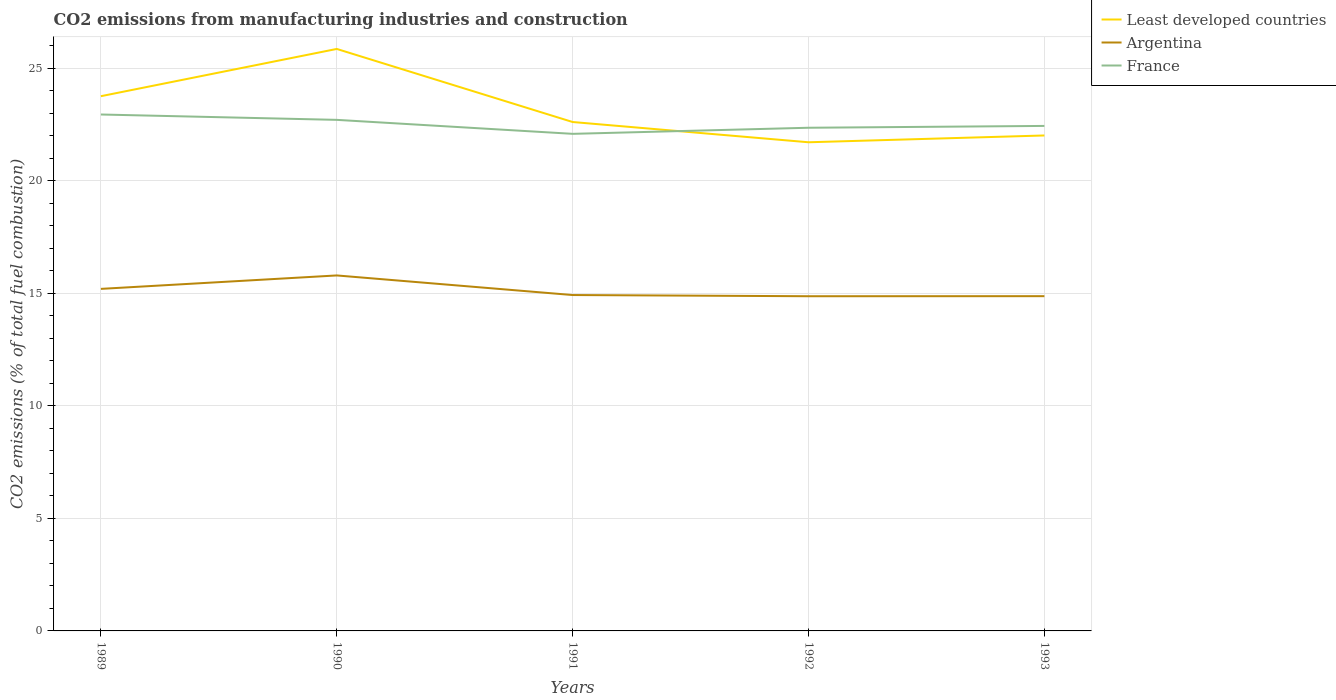How many different coloured lines are there?
Your answer should be very brief. 3. Does the line corresponding to Argentina intersect with the line corresponding to France?
Make the answer very short. No. Across all years, what is the maximum amount of CO2 emitted in Least developed countries?
Provide a short and direct response. 21.71. In which year was the amount of CO2 emitted in Least developed countries maximum?
Make the answer very short. 1992. What is the total amount of CO2 emitted in Argentina in the graph?
Your answer should be compact. -0.6. What is the difference between the highest and the second highest amount of CO2 emitted in France?
Ensure brevity in your answer.  0.86. What is the difference between the highest and the lowest amount of CO2 emitted in Argentina?
Keep it short and to the point. 2. Is the amount of CO2 emitted in Least developed countries strictly greater than the amount of CO2 emitted in Argentina over the years?
Provide a short and direct response. No. How many lines are there?
Ensure brevity in your answer.  3. How many years are there in the graph?
Provide a succinct answer. 5. Are the values on the major ticks of Y-axis written in scientific E-notation?
Provide a succinct answer. No. Where does the legend appear in the graph?
Offer a terse response. Top right. How many legend labels are there?
Give a very brief answer. 3. What is the title of the graph?
Provide a succinct answer. CO2 emissions from manufacturing industries and construction. What is the label or title of the Y-axis?
Provide a short and direct response. CO2 emissions (% of total fuel combustion). What is the CO2 emissions (% of total fuel combustion) of Least developed countries in 1989?
Provide a succinct answer. 23.75. What is the CO2 emissions (% of total fuel combustion) of Argentina in 1989?
Provide a succinct answer. 15.2. What is the CO2 emissions (% of total fuel combustion) in France in 1989?
Keep it short and to the point. 22.94. What is the CO2 emissions (% of total fuel combustion) of Least developed countries in 1990?
Your answer should be very brief. 25.85. What is the CO2 emissions (% of total fuel combustion) in Argentina in 1990?
Give a very brief answer. 15.79. What is the CO2 emissions (% of total fuel combustion) of France in 1990?
Your answer should be compact. 22.7. What is the CO2 emissions (% of total fuel combustion) of Least developed countries in 1991?
Offer a terse response. 22.61. What is the CO2 emissions (% of total fuel combustion) in Argentina in 1991?
Keep it short and to the point. 14.92. What is the CO2 emissions (% of total fuel combustion) of France in 1991?
Provide a short and direct response. 22.08. What is the CO2 emissions (% of total fuel combustion) of Least developed countries in 1992?
Make the answer very short. 21.71. What is the CO2 emissions (% of total fuel combustion) of Argentina in 1992?
Make the answer very short. 14.87. What is the CO2 emissions (% of total fuel combustion) of France in 1992?
Provide a succinct answer. 22.35. What is the CO2 emissions (% of total fuel combustion) in Least developed countries in 1993?
Offer a very short reply. 22.01. What is the CO2 emissions (% of total fuel combustion) of Argentina in 1993?
Offer a very short reply. 14.87. What is the CO2 emissions (% of total fuel combustion) of France in 1993?
Offer a terse response. 22.43. Across all years, what is the maximum CO2 emissions (% of total fuel combustion) in Least developed countries?
Your answer should be very brief. 25.85. Across all years, what is the maximum CO2 emissions (% of total fuel combustion) of Argentina?
Your response must be concise. 15.79. Across all years, what is the maximum CO2 emissions (% of total fuel combustion) in France?
Provide a short and direct response. 22.94. Across all years, what is the minimum CO2 emissions (% of total fuel combustion) of Least developed countries?
Offer a terse response. 21.71. Across all years, what is the minimum CO2 emissions (% of total fuel combustion) of Argentina?
Make the answer very short. 14.87. Across all years, what is the minimum CO2 emissions (% of total fuel combustion) of France?
Your response must be concise. 22.08. What is the total CO2 emissions (% of total fuel combustion) in Least developed countries in the graph?
Your answer should be very brief. 115.93. What is the total CO2 emissions (% of total fuel combustion) in Argentina in the graph?
Your answer should be compact. 75.65. What is the total CO2 emissions (% of total fuel combustion) in France in the graph?
Your answer should be compact. 112.51. What is the difference between the CO2 emissions (% of total fuel combustion) of Least developed countries in 1989 and that in 1990?
Your answer should be very brief. -2.1. What is the difference between the CO2 emissions (% of total fuel combustion) of Argentina in 1989 and that in 1990?
Your response must be concise. -0.6. What is the difference between the CO2 emissions (% of total fuel combustion) of France in 1989 and that in 1990?
Make the answer very short. 0.24. What is the difference between the CO2 emissions (% of total fuel combustion) in Least developed countries in 1989 and that in 1991?
Provide a succinct answer. 1.15. What is the difference between the CO2 emissions (% of total fuel combustion) in Argentina in 1989 and that in 1991?
Your response must be concise. 0.27. What is the difference between the CO2 emissions (% of total fuel combustion) of France in 1989 and that in 1991?
Your answer should be very brief. 0.86. What is the difference between the CO2 emissions (% of total fuel combustion) in Least developed countries in 1989 and that in 1992?
Offer a terse response. 2.05. What is the difference between the CO2 emissions (% of total fuel combustion) of Argentina in 1989 and that in 1992?
Your answer should be compact. 0.33. What is the difference between the CO2 emissions (% of total fuel combustion) in France in 1989 and that in 1992?
Give a very brief answer. 0.59. What is the difference between the CO2 emissions (% of total fuel combustion) of Least developed countries in 1989 and that in 1993?
Offer a very short reply. 1.74. What is the difference between the CO2 emissions (% of total fuel combustion) in Argentina in 1989 and that in 1993?
Provide a short and direct response. 0.32. What is the difference between the CO2 emissions (% of total fuel combustion) in France in 1989 and that in 1993?
Ensure brevity in your answer.  0.51. What is the difference between the CO2 emissions (% of total fuel combustion) of Least developed countries in 1990 and that in 1991?
Your answer should be compact. 3.25. What is the difference between the CO2 emissions (% of total fuel combustion) in Argentina in 1990 and that in 1991?
Your answer should be very brief. 0.87. What is the difference between the CO2 emissions (% of total fuel combustion) in France in 1990 and that in 1991?
Keep it short and to the point. 0.62. What is the difference between the CO2 emissions (% of total fuel combustion) of Least developed countries in 1990 and that in 1992?
Offer a terse response. 4.15. What is the difference between the CO2 emissions (% of total fuel combustion) in Argentina in 1990 and that in 1992?
Offer a very short reply. 0.92. What is the difference between the CO2 emissions (% of total fuel combustion) in France in 1990 and that in 1992?
Give a very brief answer. 0.35. What is the difference between the CO2 emissions (% of total fuel combustion) of Least developed countries in 1990 and that in 1993?
Your answer should be compact. 3.84. What is the difference between the CO2 emissions (% of total fuel combustion) in Argentina in 1990 and that in 1993?
Offer a very short reply. 0.92. What is the difference between the CO2 emissions (% of total fuel combustion) in France in 1990 and that in 1993?
Your response must be concise. 0.27. What is the difference between the CO2 emissions (% of total fuel combustion) of Least developed countries in 1991 and that in 1992?
Your response must be concise. 0.9. What is the difference between the CO2 emissions (% of total fuel combustion) of Argentina in 1991 and that in 1992?
Provide a short and direct response. 0.05. What is the difference between the CO2 emissions (% of total fuel combustion) in France in 1991 and that in 1992?
Offer a terse response. -0.27. What is the difference between the CO2 emissions (% of total fuel combustion) in Least developed countries in 1991 and that in 1993?
Your response must be concise. 0.6. What is the difference between the CO2 emissions (% of total fuel combustion) of France in 1991 and that in 1993?
Provide a succinct answer. -0.35. What is the difference between the CO2 emissions (% of total fuel combustion) in Least developed countries in 1992 and that in 1993?
Provide a short and direct response. -0.3. What is the difference between the CO2 emissions (% of total fuel combustion) of Argentina in 1992 and that in 1993?
Ensure brevity in your answer.  -0. What is the difference between the CO2 emissions (% of total fuel combustion) of France in 1992 and that in 1993?
Provide a short and direct response. -0.08. What is the difference between the CO2 emissions (% of total fuel combustion) of Least developed countries in 1989 and the CO2 emissions (% of total fuel combustion) of Argentina in 1990?
Provide a short and direct response. 7.96. What is the difference between the CO2 emissions (% of total fuel combustion) of Least developed countries in 1989 and the CO2 emissions (% of total fuel combustion) of France in 1990?
Your answer should be compact. 1.05. What is the difference between the CO2 emissions (% of total fuel combustion) in Argentina in 1989 and the CO2 emissions (% of total fuel combustion) in France in 1990?
Offer a very short reply. -7.51. What is the difference between the CO2 emissions (% of total fuel combustion) of Least developed countries in 1989 and the CO2 emissions (% of total fuel combustion) of Argentina in 1991?
Make the answer very short. 8.83. What is the difference between the CO2 emissions (% of total fuel combustion) in Least developed countries in 1989 and the CO2 emissions (% of total fuel combustion) in France in 1991?
Offer a terse response. 1.67. What is the difference between the CO2 emissions (% of total fuel combustion) in Argentina in 1989 and the CO2 emissions (% of total fuel combustion) in France in 1991?
Your answer should be very brief. -6.89. What is the difference between the CO2 emissions (% of total fuel combustion) in Least developed countries in 1989 and the CO2 emissions (% of total fuel combustion) in Argentina in 1992?
Ensure brevity in your answer.  8.89. What is the difference between the CO2 emissions (% of total fuel combustion) in Least developed countries in 1989 and the CO2 emissions (% of total fuel combustion) in France in 1992?
Your answer should be compact. 1.4. What is the difference between the CO2 emissions (% of total fuel combustion) of Argentina in 1989 and the CO2 emissions (% of total fuel combustion) of France in 1992?
Your response must be concise. -7.16. What is the difference between the CO2 emissions (% of total fuel combustion) in Least developed countries in 1989 and the CO2 emissions (% of total fuel combustion) in Argentina in 1993?
Your response must be concise. 8.88. What is the difference between the CO2 emissions (% of total fuel combustion) of Least developed countries in 1989 and the CO2 emissions (% of total fuel combustion) of France in 1993?
Your response must be concise. 1.32. What is the difference between the CO2 emissions (% of total fuel combustion) of Argentina in 1989 and the CO2 emissions (% of total fuel combustion) of France in 1993?
Offer a terse response. -7.24. What is the difference between the CO2 emissions (% of total fuel combustion) in Least developed countries in 1990 and the CO2 emissions (% of total fuel combustion) in Argentina in 1991?
Give a very brief answer. 10.93. What is the difference between the CO2 emissions (% of total fuel combustion) of Least developed countries in 1990 and the CO2 emissions (% of total fuel combustion) of France in 1991?
Your response must be concise. 3.77. What is the difference between the CO2 emissions (% of total fuel combustion) of Argentina in 1990 and the CO2 emissions (% of total fuel combustion) of France in 1991?
Provide a succinct answer. -6.29. What is the difference between the CO2 emissions (% of total fuel combustion) in Least developed countries in 1990 and the CO2 emissions (% of total fuel combustion) in Argentina in 1992?
Your answer should be compact. 10.99. What is the difference between the CO2 emissions (% of total fuel combustion) in Least developed countries in 1990 and the CO2 emissions (% of total fuel combustion) in France in 1992?
Make the answer very short. 3.5. What is the difference between the CO2 emissions (% of total fuel combustion) of Argentina in 1990 and the CO2 emissions (% of total fuel combustion) of France in 1992?
Give a very brief answer. -6.56. What is the difference between the CO2 emissions (% of total fuel combustion) in Least developed countries in 1990 and the CO2 emissions (% of total fuel combustion) in Argentina in 1993?
Offer a very short reply. 10.98. What is the difference between the CO2 emissions (% of total fuel combustion) in Least developed countries in 1990 and the CO2 emissions (% of total fuel combustion) in France in 1993?
Your answer should be compact. 3.42. What is the difference between the CO2 emissions (% of total fuel combustion) of Argentina in 1990 and the CO2 emissions (% of total fuel combustion) of France in 1993?
Your response must be concise. -6.64. What is the difference between the CO2 emissions (% of total fuel combustion) of Least developed countries in 1991 and the CO2 emissions (% of total fuel combustion) of Argentina in 1992?
Your answer should be very brief. 7.74. What is the difference between the CO2 emissions (% of total fuel combustion) in Least developed countries in 1991 and the CO2 emissions (% of total fuel combustion) in France in 1992?
Your answer should be very brief. 0.25. What is the difference between the CO2 emissions (% of total fuel combustion) in Argentina in 1991 and the CO2 emissions (% of total fuel combustion) in France in 1992?
Ensure brevity in your answer.  -7.43. What is the difference between the CO2 emissions (% of total fuel combustion) in Least developed countries in 1991 and the CO2 emissions (% of total fuel combustion) in Argentina in 1993?
Your answer should be very brief. 7.74. What is the difference between the CO2 emissions (% of total fuel combustion) of Least developed countries in 1991 and the CO2 emissions (% of total fuel combustion) of France in 1993?
Your response must be concise. 0.17. What is the difference between the CO2 emissions (% of total fuel combustion) of Argentina in 1991 and the CO2 emissions (% of total fuel combustion) of France in 1993?
Provide a short and direct response. -7.51. What is the difference between the CO2 emissions (% of total fuel combustion) in Least developed countries in 1992 and the CO2 emissions (% of total fuel combustion) in Argentina in 1993?
Provide a short and direct response. 6.84. What is the difference between the CO2 emissions (% of total fuel combustion) in Least developed countries in 1992 and the CO2 emissions (% of total fuel combustion) in France in 1993?
Provide a short and direct response. -0.73. What is the difference between the CO2 emissions (% of total fuel combustion) in Argentina in 1992 and the CO2 emissions (% of total fuel combustion) in France in 1993?
Provide a short and direct response. -7.57. What is the average CO2 emissions (% of total fuel combustion) of Least developed countries per year?
Give a very brief answer. 23.19. What is the average CO2 emissions (% of total fuel combustion) in Argentina per year?
Offer a terse response. 15.13. What is the average CO2 emissions (% of total fuel combustion) of France per year?
Offer a terse response. 22.5. In the year 1989, what is the difference between the CO2 emissions (% of total fuel combustion) in Least developed countries and CO2 emissions (% of total fuel combustion) in Argentina?
Your response must be concise. 8.56. In the year 1989, what is the difference between the CO2 emissions (% of total fuel combustion) of Least developed countries and CO2 emissions (% of total fuel combustion) of France?
Keep it short and to the point. 0.81. In the year 1989, what is the difference between the CO2 emissions (% of total fuel combustion) in Argentina and CO2 emissions (% of total fuel combustion) in France?
Your response must be concise. -7.75. In the year 1990, what is the difference between the CO2 emissions (% of total fuel combustion) in Least developed countries and CO2 emissions (% of total fuel combustion) in Argentina?
Ensure brevity in your answer.  10.06. In the year 1990, what is the difference between the CO2 emissions (% of total fuel combustion) in Least developed countries and CO2 emissions (% of total fuel combustion) in France?
Provide a succinct answer. 3.15. In the year 1990, what is the difference between the CO2 emissions (% of total fuel combustion) in Argentina and CO2 emissions (% of total fuel combustion) in France?
Ensure brevity in your answer.  -6.91. In the year 1991, what is the difference between the CO2 emissions (% of total fuel combustion) in Least developed countries and CO2 emissions (% of total fuel combustion) in Argentina?
Provide a short and direct response. 7.69. In the year 1991, what is the difference between the CO2 emissions (% of total fuel combustion) in Least developed countries and CO2 emissions (% of total fuel combustion) in France?
Your answer should be compact. 0.53. In the year 1991, what is the difference between the CO2 emissions (% of total fuel combustion) in Argentina and CO2 emissions (% of total fuel combustion) in France?
Make the answer very short. -7.16. In the year 1992, what is the difference between the CO2 emissions (% of total fuel combustion) of Least developed countries and CO2 emissions (% of total fuel combustion) of Argentina?
Your response must be concise. 6.84. In the year 1992, what is the difference between the CO2 emissions (% of total fuel combustion) of Least developed countries and CO2 emissions (% of total fuel combustion) of France?
Provide a short and direct response. -0.65. In the year 1992, what is the difference between the CO2 emissions (% of total fuel combustion) of Argentina and CO2 emissions (% of total fuel combustion) of France?
Give a very brief answer. -7.48. In the year 1993, what is the difference between the CO2 emissions (% of total fuel combustion) of Least developed countries and CO2 emissions (% of total fuel combustion) of Argentina?
Your answer should be very brief. 7.14. In the year 1993, what is the difference between the CO2 emissions (% of total fuel combustion) in Least developed countries and CO2 emissions (% of total fuel combustion) in France?
Offer a terse response. -0.42. In the year 1993, what is the difference between the CO2 emissions (% of total fuel combustion) of Argentina and CO2 emissions (% of total fuel combustion) of France?
Provide a short and direct response. -7.56. What is the ratio of the CO2 emissions (% of total fuel combustion) in Least developed countries in 1989 to that in 1990?
Provide a short and direct response. 0.92. What is the ratio of the CO2 emissions (% of total fuel combustion) in Argentina in 1989 to that in 1990?
Your answer should be very brief. 0.96. What is the ratio of the CO2 emissions (% of total fuel combustion) in France in 1989 to that in 1990?
Your response must be concise. 1.01. What is the ratio of the CO2 emissions (% of total fuel combustion) of Least developed countries in 1989 to that in 1991?
Ensure brevity in your answer.  1.05. What is the ratio of the CO2 emissions (% of total fuel combustion) of Argentina in 1989 to that in 1991?
Your answer should be compact. 1.02. What is the ratio of the CO2 emissions (% of total fuel combustion) in France in 1989 to that in 1991?
Ensure brevity in your answer.  1.04. What is the ratio of the CO2 emissions (% of total fuel combustion) in Least developed countries in 1989 to that in 1992?
Ensure brevity in your answer.  1.09. What is the ratio of the CO2 emissions (% of total fuel combustion) of Argentina in 1989 to that in 1992?
Give a very brief answer. 1.02. What is the ratio of the CO2 emissions (% of total fuel combustion) of France in 1989 to that in 1992?
Provide a short and direct response. 1.03. What is the ratio of the CO2 emissions (% of total fuel combustion) in Least developed countries in 1989 to that in 1993?
Your response must be concise. 1.08. What is the ratio of the CO2 emissions (% of total fuel combustion) of Argentina in 1989 to that in 1993?
Offer a terse response. 1.02. What is the ratio of the CO2 emissions (% of total fuel combustion) in France in 1989 to that in 1993?
Offer a terse response. 1.02. What is the ratio of the CO2 emissions (% of total fuel combustion) in Least developed countries in 1990 to that in 1991?
Your answer should be compact. 1.14. What is the ratio of the CO2 emissions (% of total fuel combustion) in Argentina in 1990 to that in 1991?
Offer a very short reply. 1.06. What is the ratio of the CO2 emissions (% of total fuel combustion) in France in 1990 to that in 1991?
Make the answer very short. 1.03. What is the ratio of the CO2 emissions (% of total fuel combustion) in Least developed countries in 1990 to that in 1992?
Keep it short and to the point. 1.19. What is the ratio of the CO2 emissions (% of total fuel combustion) in Argentina in 1990 to that in 1992?
Offer a very short reply. 1.06. What is the ratio of the CO2 emissions (% of total fuel combustion) in France in 1990 to that in 1992?
Your response must be concise. 1.02. What is the ratio of the CO2 emissions (% of total fuel combustion) of Least developed countries in 1990 to that in 1993?
Your response must be concise. 1.17. What is the ratio of the CO2 emissions (% of total fuel combustion) of Argentina in 1990 to that in 1993?
Provide a succinct answer. 1.06. What is the ratio of the CO2 emissions (% of total fuel combustion) of Least developed countries in 1991 to that in 1992?
Provide a short and direct response. 1.04. What is the ratio of the CO2 emissions (% of total fuel combustion) in Argentina in 1991 to that in 1992?
Your answer should be compact. 1. What is the ratio of the CO2 emissions (% of total fuel combustion) of France in 1991 to that in 1992?
Give a very brief answer. 0.99. What is the ratio of the CO2 emissions (% of total fuel combustion) in Least developed countries in 1991 to that in 1993?
Provide a succinct answer. 1.03. What is the ratio of the CO2 emissions (% of total fuel combustion) in Argentina in 1991 to that in 1993?
Ensure brevity in your answer.  1. What is the ratio of the CO2 emissions (% of total fuel combustion) in France in 1991 to that in 1993?
Your response must be concise. 0.98. What is the ratio of the CO2 emissions (% of total fuel combustion) in Least developed countries in 1992 to that in 1993?
Offer a terse response. 0.99. What is the ratio of the CO2 emissions (% of total fuel combustion) of France in 1992 to that in 1993?
Provide a short and direct response. 1. What is the difference between the highest and the second highest CO2 emissions (% of total fuel combustion) in Least developed countries?
Make the answer very short. 2.1. What is the difference between the highest and the second highest CO2 emissions (% of total fuel combustion) of Argentina?
Provide a short and direct response. 0.6. What is the difference between the highest and the second highest CO2 emissions (% of total fuel combustion) in France?
Your answer should be compact. 0.24. What is the difference between the highest and the lowest CO2 emissions (% of total fuel combustion) of Least developed countries?
Keep it short and to the point. 4.15. What is the difference between the highest and the lowest CO2 emissions (% of total fuel combustion) of Argentina?
Your response must be concise. 0.92. What is the difference between the highest and the lowest CO2 emissions (% of total fuel combustion) of France?
Your response must be concise. 0.86. 